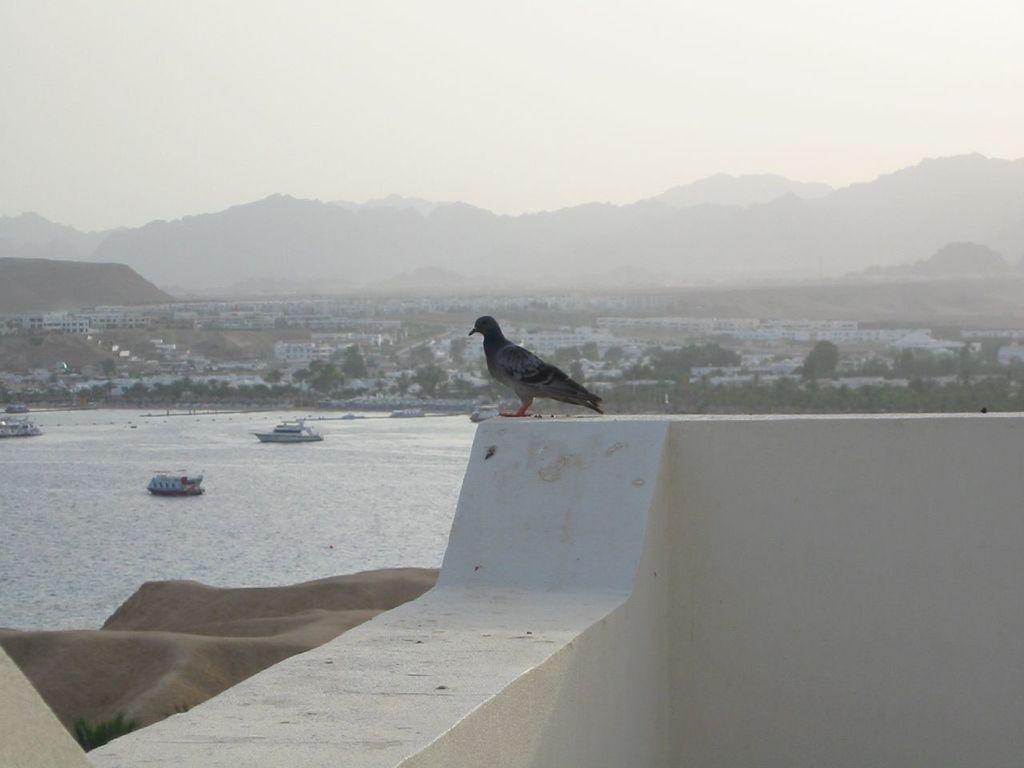Describe this image in one or two sentences. In this image we can see a pigeon on the wall, also we can see some houses, trees, there are some boats on the river, also we can see the sky. 